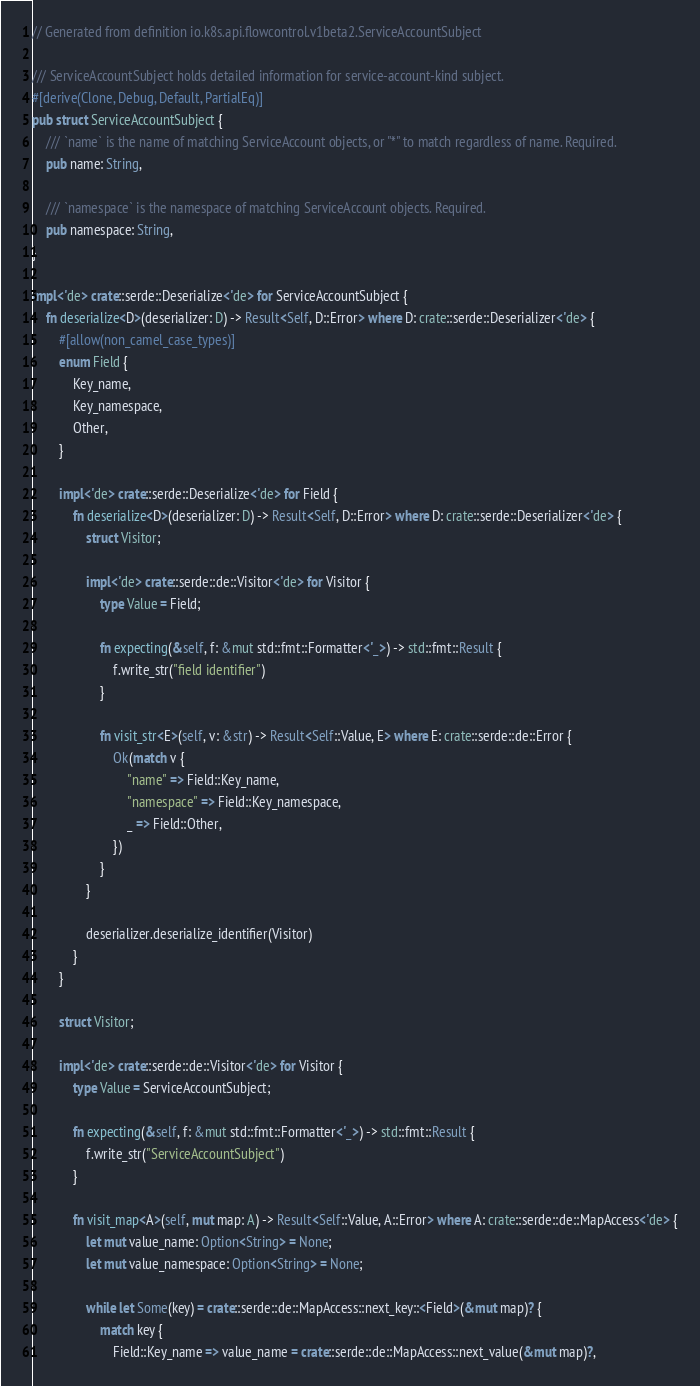<code> <loc_0><loc_0><loc_500><loc_500><_Rust_>// Generated from definition io.k8s.api.flowcontrol.v1beta2.ServiceAccountSubject

/// ServiceAccountSubject holds detailed information for service-account-kind subject.
#[derive(Clone, Debug, Default, PartialEq)]
pub struct ServiceAccountSubject {
    /// `name` is the name of matching ServiceAccount objects, or "*" to match regardless of name. Required.
    pub name: String,

    /// `namespace` is the namespace of matching ServiceAccount objects. Required.
    pub namespace: String,
}

impl<'de> crate::serde::Deserialize<'de> for ServiceAccountSubject {
    fn deserialize<D>(deserializer: D) -> Result<Self, D::Error> where D: crate::serde::Deserializer<'de> {
        #[allow(non_camel_case_types)]
        enum Field {
            Key_name,
            Key_namespace,
            Other,
        }

        impl<'de> crate::serde::Deserialize<'de> for Field {
            fn deserialize<D>(deserializer: D) -> Result<Self, D::Error> where D: crate::serde::Deserializer<'de> {
                struct Visitor;

                impl<'de> crate::serde::de::Visitor<'de> for Visitor {
                    type Value = Field;

                    fn expecting(&self, f: &mut std::fmt::Formatter<'_>) -> std::fmt::Result {
                        f.write_str("field identifier")
                    }

                    fn visit_str<E>(self, v: &str) -> Result<Self::Value, E> where E: crate::serde::de::Error {
                        Ok(match v {
                            "name" => Field::Key_name,
                            "namespace" => Field::Key_namespace,
                            _ => Field::Other,
                        })
                    }
                }

                deserializer.deserialize_identifier(Visitor)
            }
        }

        struct Visitor;

        impl<'de> crate::serde::de::Visitor<'de> for Visitor {
            type Value = ServiceAccountSubject;

            fn expecting(&self, f: &mut std::fmt::Formatter<'_>) -> std::fmt::Result {
                f.write_str("ServiceAccountSubject")
            }

            fn visit_map<A>(self, mut map: A) -> Result<Self::Value, A::Error> where A: crate::serde::de::MapAccess<'de> {
                let mut value_name: Option<String> = None;
                let mut value_namespace: Option<String> = None;

                while let Some(key) = crate::serde::de::MapAccess::next_key::<Field>(&mut map)? {
                    match key {
                        Field::Key_name => value_name = crate::serde::de::MapAccess::next_value(&mut map)?,</code> 